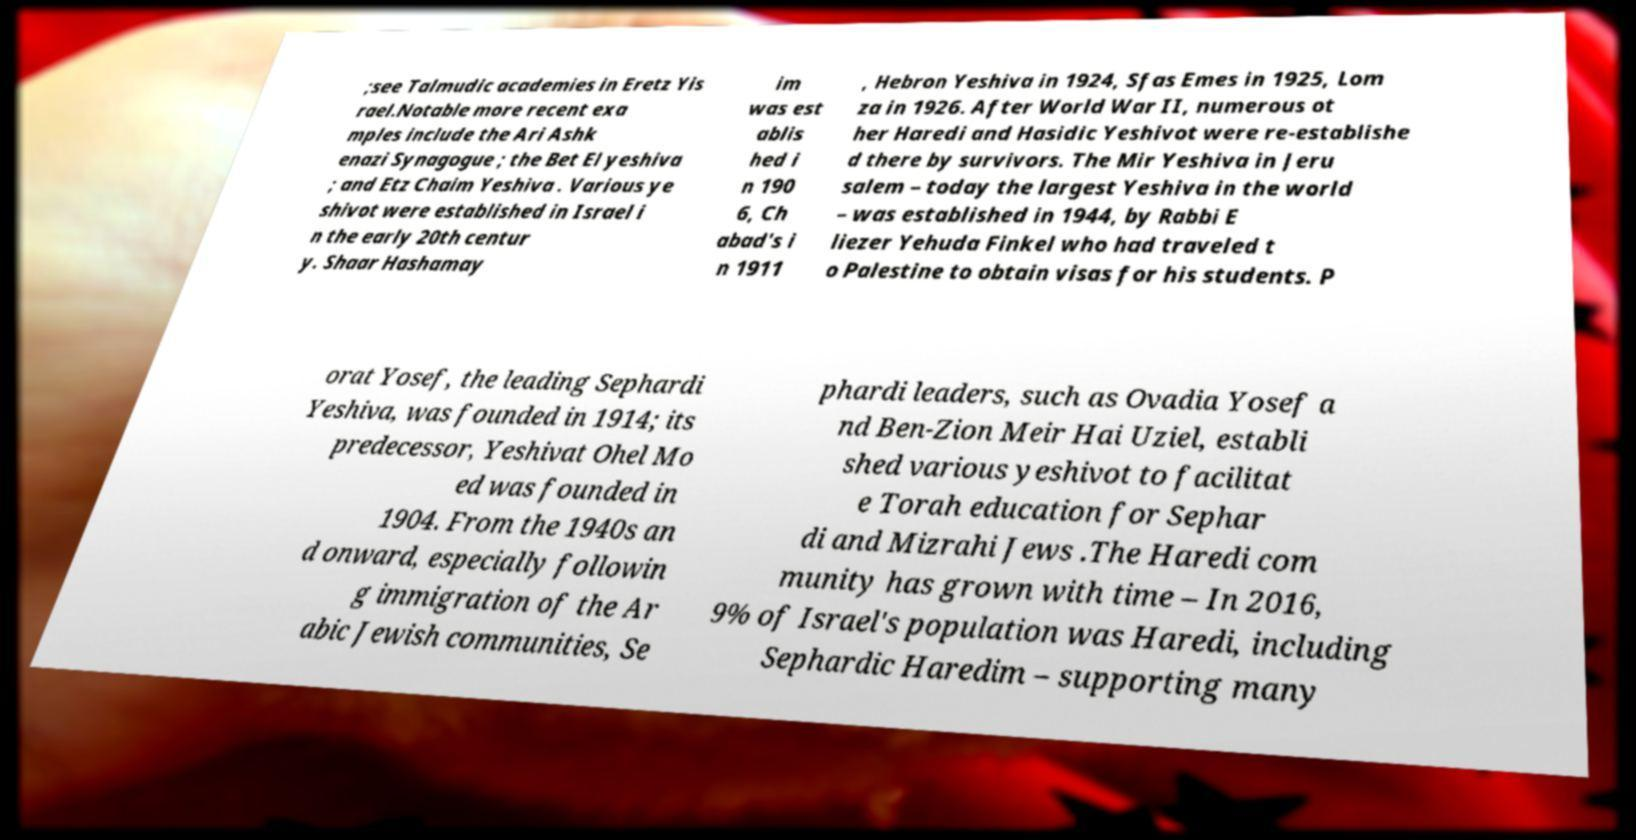I need the written content from this picture converted into text. Can you do that? ;see Talmudic academies in Eretz Yis rael.Notable more recent exa mples include the Ari Ashk enazi Synagogue ; the Bet El yeshiva ; and Etz Chaim Yeshiva . Various ye shivot were established in Israel i n the early 20th centur y. Shaar Hashamay im was est ablis hed i n 190 6, Ch abad's i n 1911 , Hebron Yeshiva in 1924, Sfas Emes in 1925, Lom za in 1926. After World War II, numerous ot her Haredi and Hasidic Yeshivot were re-establishe d there by survivors. The Mir Yeshiva in Jeru salem – today the largest Yeshiva in the world – was established in 1944, by Rabbi E liezer Yehuda Finkel who had traveled t o Palestine to obtain visas for his students. P orat Yosef, the leading Sephardi Yeshiva, was founded in 1914; its predecessor, Yeshivat Ohel Mo ed was founded in 1904. From the 1940s an d onward, especially followin g immigration of the Ar abic Jewish communities, Se phardi leaders, such as Ovadia Yosef a nd Ben-Zion Meir Hai Uziel, establi shed various yeshivot to facilitat e Torah education for Sephar di and Mizrahi Jews .The Haredi com munity has grown with time – In 2016, 9% of Israel's population was Haredi, including Sephardic Haredim – supporting many 